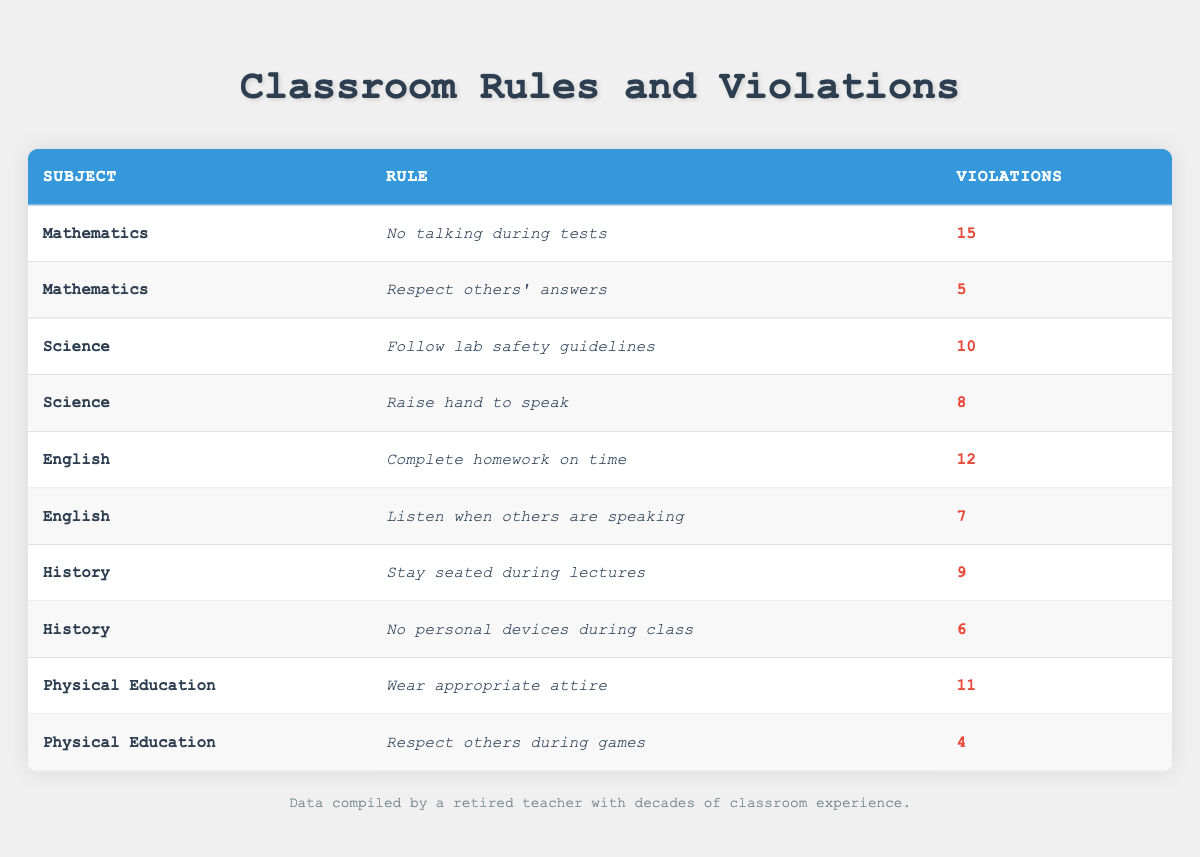What is the highest number of rule violations, and which subject does it relate to? The highest number of rule violations is 15, which relates to the rule "No talking during tests" in Mathematics.
Answer: 15, Mathematics How many total violations were recorded for Science? There are two rules listed for Science: "Follow lab safety guidelines" with 10 violations and "Raise hand to speak" with 8 violations. Adding them together gives 10 + 8 = 18 violations.
Answer: 18 Which subject has the fewest violations, and how many violations does it have? The fewest violations are for the rule "Respect others during games" in Physical Education with only 4 violations.
Answer: Physical Education, 4 Is the rule "Complete homework on time" associated with more violations than the rule "Respect others’ answers"? "Complete homework on time" has 12 violations while "Respect others' answers" has 5 violations, making the first rule associated with more violations.
Answer: Yes What is the total number of violations for all subjects combined? To find the total number of violations, we add all the reported violations together: 15 + 5 + 10 + 8 + 12 + 7 + 9 + 6 + 11 + 4 = 87.
Answer: 87 Which subject has the most rules reported in the table? Upon examining the table, Mathematics, Science, English, History, and Physical Education each have 2 rules listed, hence no single subject has more rules than the others.
Answer: None, all have 2 rules What is the average number of violations per rule across all subjects? There are 10 total rules reported. The sum of all violations is 87. To find the average, divide the total violations by the number of rules: 87/10 = 8.7.
Answer: 8.7 Are there more violations reported in English than in Mathematics? In English, the total number of violations is 19 (12 + 7), while in Mathematics, it is 20 (15 + 5). Therefore, there are fewer violations in English than in Mathematics.
Answer: No What is the total violation count for rules associated with Physical Education? Physical Education has two rules: "Wear appropriate attire" with 11 violations and "Respect others during games" with 4 violations. Adding them gives 11 + 4 = 15 violations.
Answer: 15 